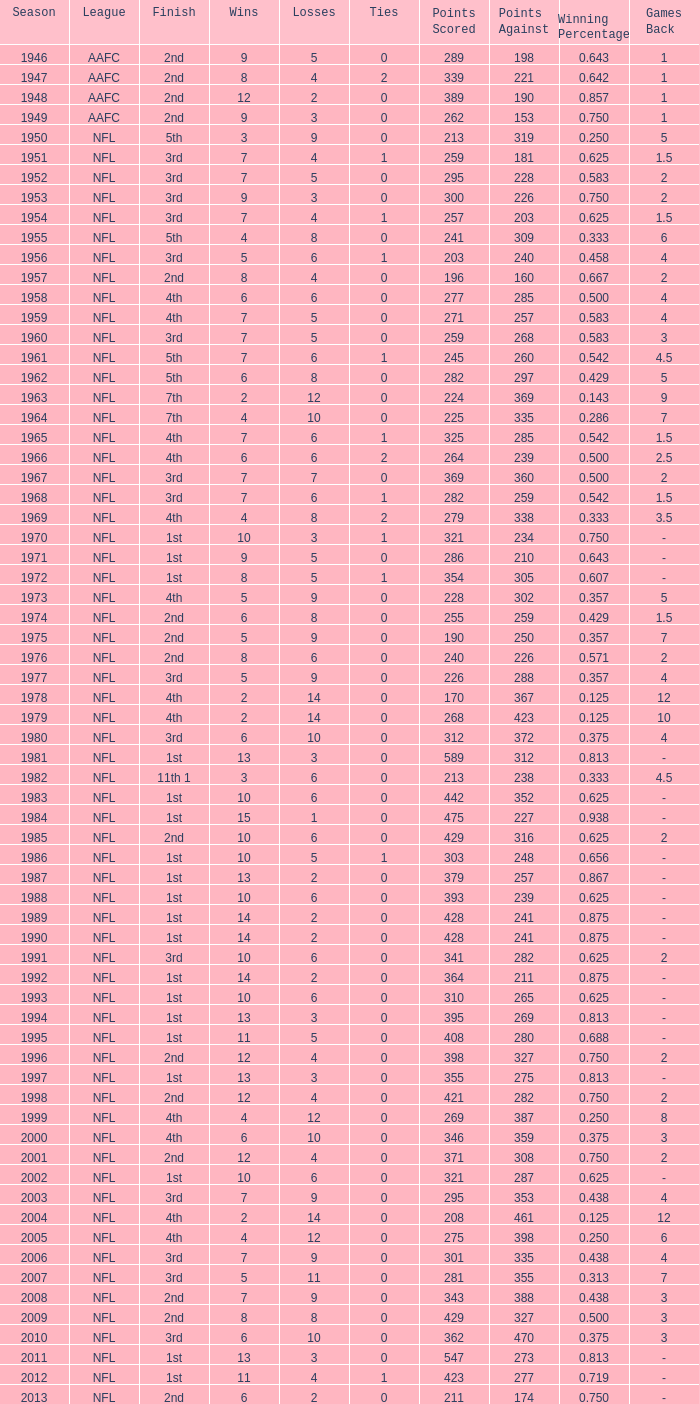What is the number of losses when the ties are lesser than 0? 0.0. 